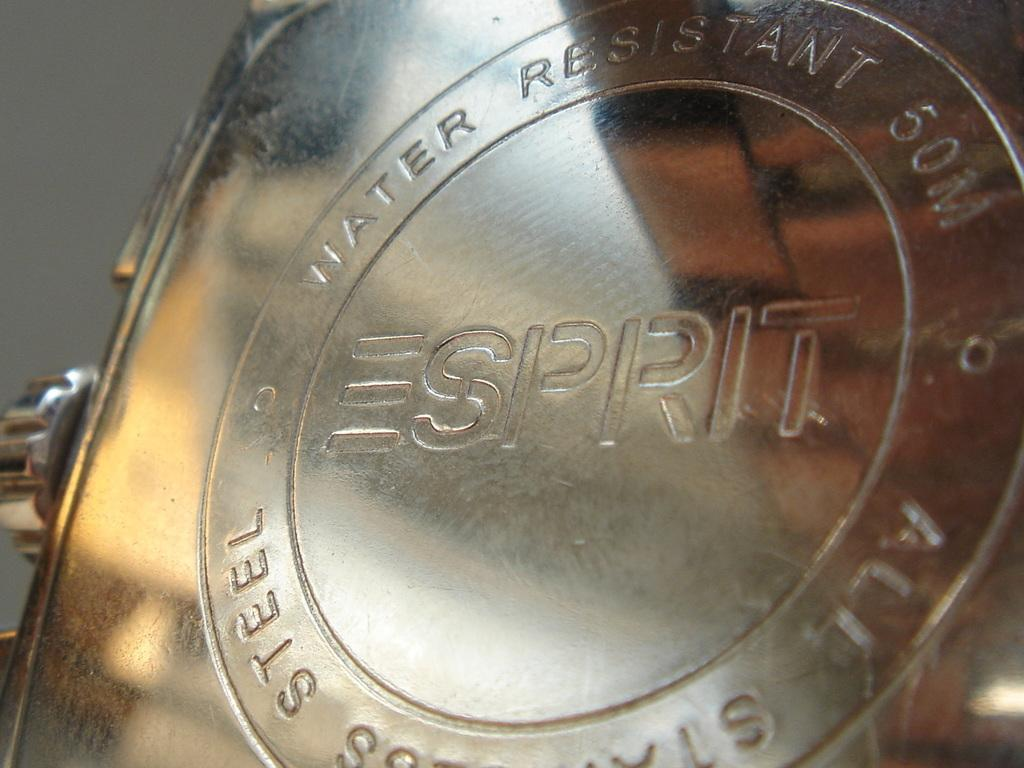Provide a one-sentence caption for the provided image. The metal, stamped by the Esprit brand, is water-resistant. 